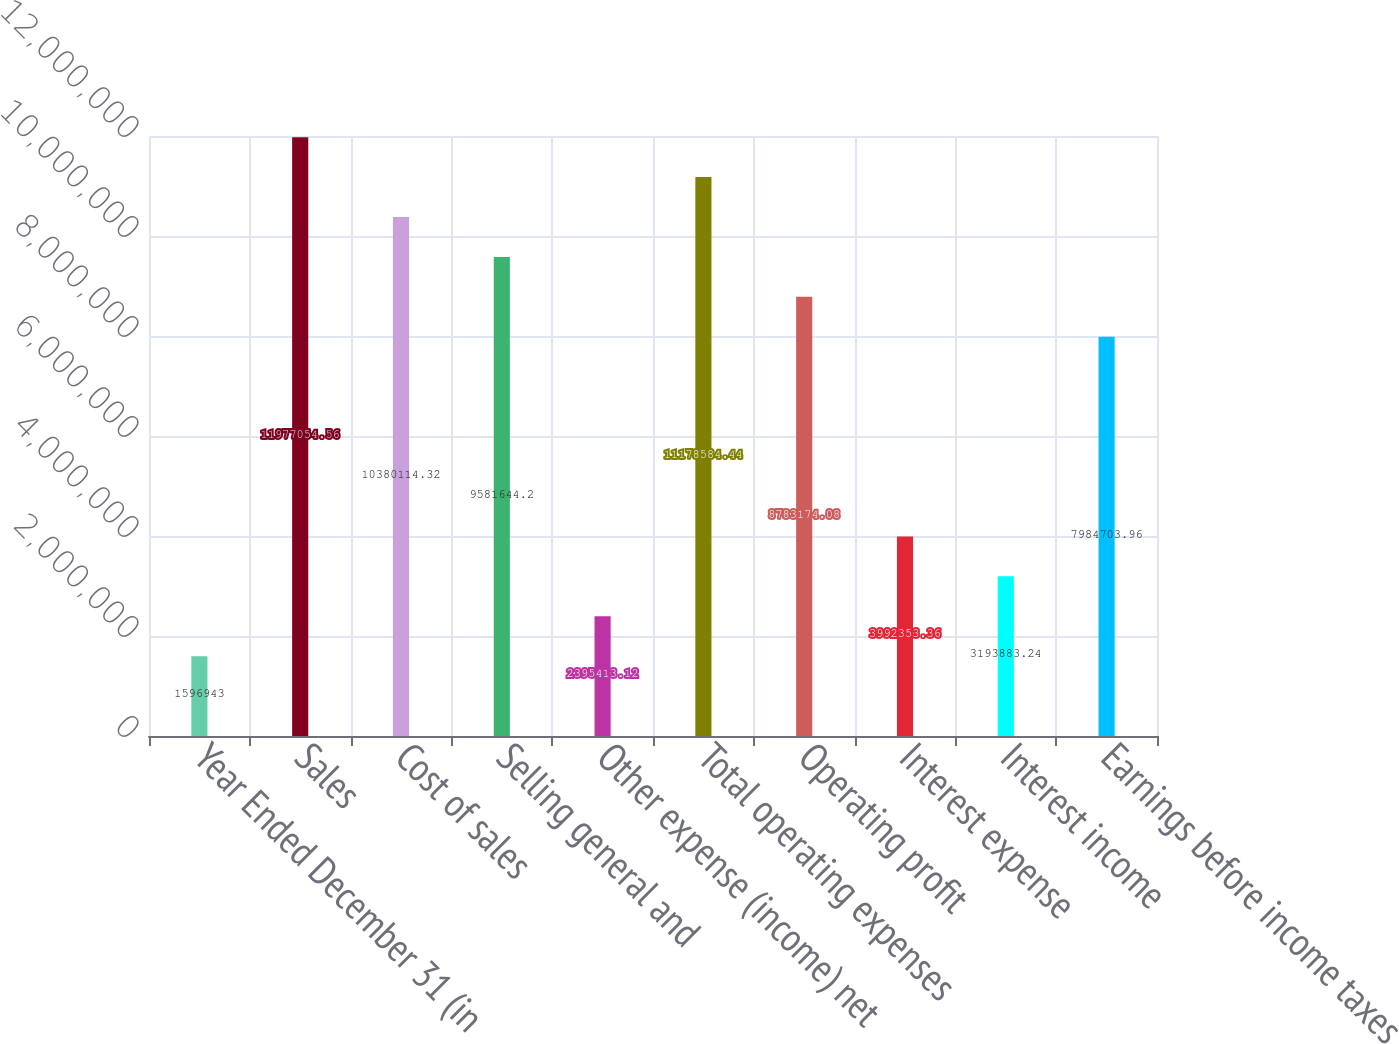Convert chart to OTSL. <chart><loc_0><loc_0><loc_500><loc_500><bar_chart><fcel>Year Ended December 31 (in<fcel>Sales<fcel>Cost of sales<fcel>Selling general and<fcel>Other expense (income) net<fcel>Total operating expenses<fcel>Operating profit<fcel>Interest expense<fcel>Interest income<fcel>Earnings before income taxes<nl><fcel>1.59694e+06<fcel>1.19771e+07<fcel>1.03801e+07<fcel>9.58164e+06<fcel>2.39541e+06<fcel>1.11786e+07<fcel>8.78317e+06<fcel>3.99235e+06<fcel>3.19388e+06<fcel>7.9847e+06<nl></chart> 